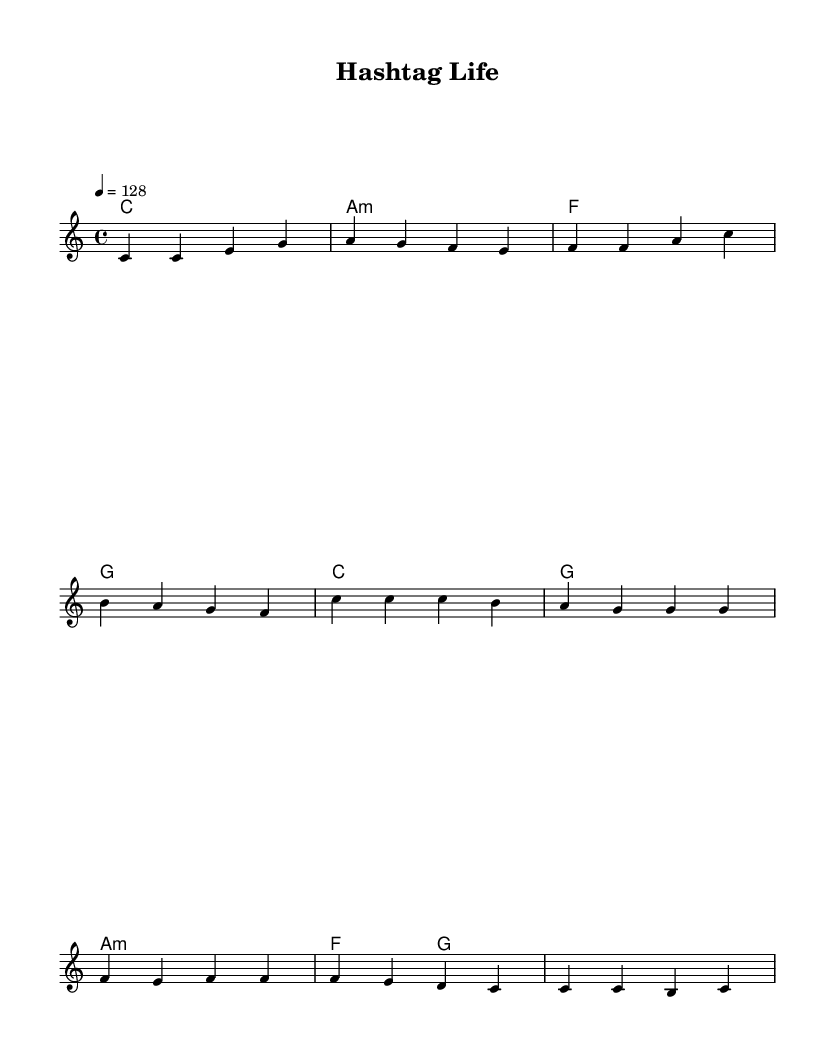What is the key signature of this music? The key signature is C major, which has no sharps or flats.
Answer: C major What is the time signature of this piece? The time signature is indicated as 4/4, meaning there are four beats per measure.
Answer: 4/4 What is the tempo of the song? The tempo is indicated with "4 = 128," meaning there are 128 beats per minute.
Answer: 128 How many measures are in the verse? The verse contains 4 measures as seen in the melody notation.
Answer: 4 Which chord precedes the chorus? The chord before the chorus is C major, which is the first chord in the chord progression.
Answer: C What is the main theme of the lyrics? The main theme revolves around life on social media, as indicated by the repeated use of "hashtag."
Answer: Hashtag life How do the word lengths in the chorus compare to those in the verse? The chorus has shorter syllables overall, with repetitive phrases that create a punchy rhythm.
Answer: Shorter 